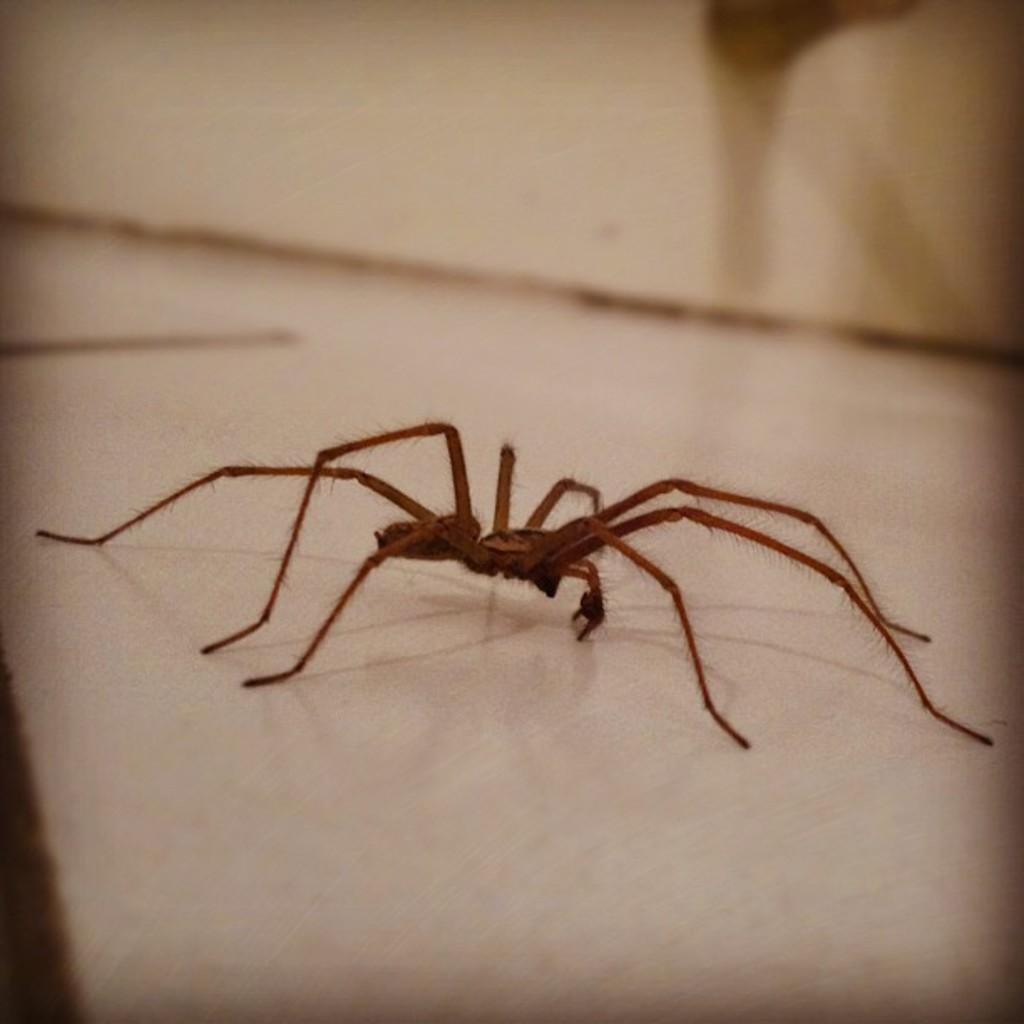Can you describe this image briefly? In this image we can see a spider on the white color surface. 